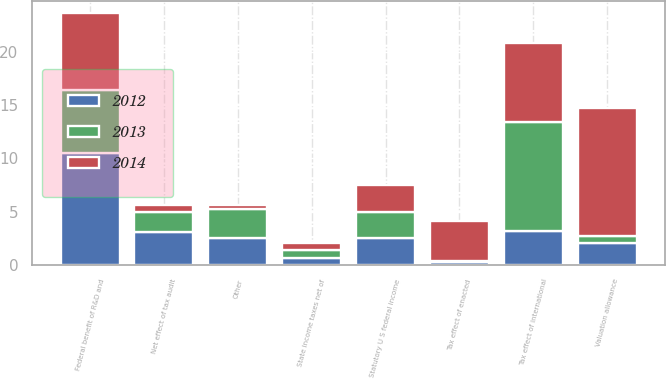Convert chart to OTSL. <chart><loc_0><loc_0><loc_500><loc_500><stacked_bar_chart><ecel><fcel>Statutory U S federal income<fcel>State income taxes net of<fcel>Federal benefit of R&D and<fcel>Tax effect of international<fcel>Net effect of tax audit<fcel>Tax effect of enacted<fcel>Valuation allowance<fcel>Other<nl><fcel>2012<fcel>2.5<fcel>0.7<fcel>10.5<fcel>3.2<fcel>3.1<fcel>0.3<fcel>2.1<fcel>2.5<nl><fcel>2013<fcel>2.5<fcel>0.7<fcel>5.9<fcel>10.2<fcel>1.9<fcel>0.1<fcel>0.6<fcel>2.8<nl><fcel>2014<fcel>2.5<fcel>0.7<fcel>7.2<fcel>7.4<fcel>0.6<fcel>3.7<fcel>12<fcel>0.3<nl></chart> 